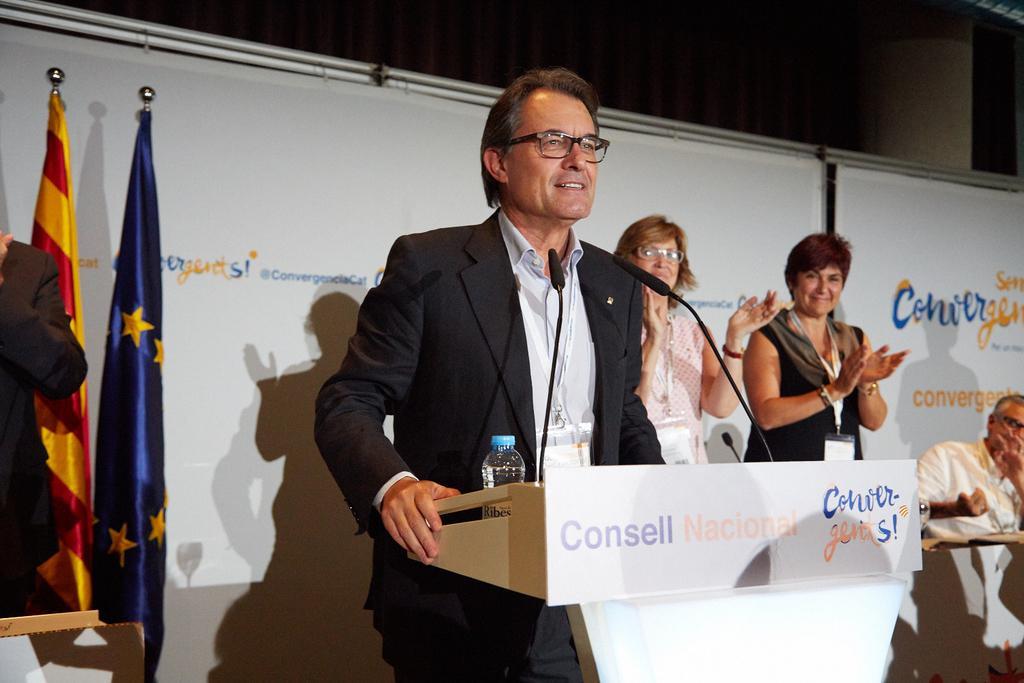How would you summarize this image in a sentence or two? In this picture we can see a man wore blazer, spectacle and standing at the podium and speaking on mics, bottle and in the background we can see banners, flags and some people clapping hands and smiling. 